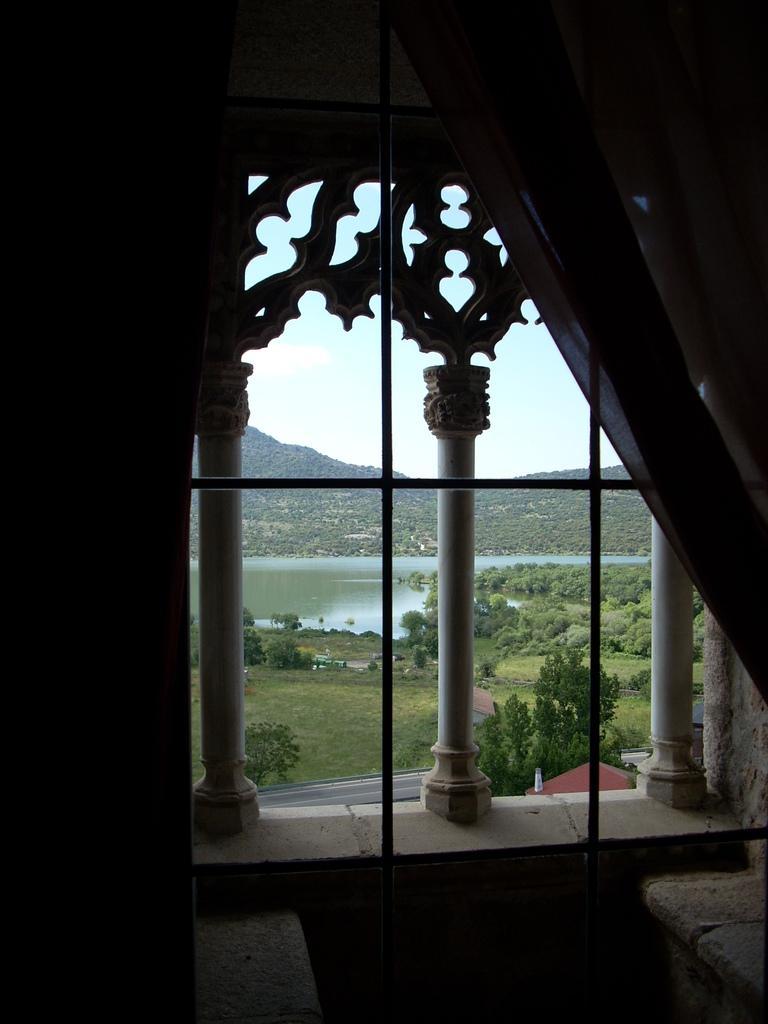Please provide a concise description of this image. In this image I can see the curtains. I can see the water and the trees behind the window. At the top I can see the sky. 